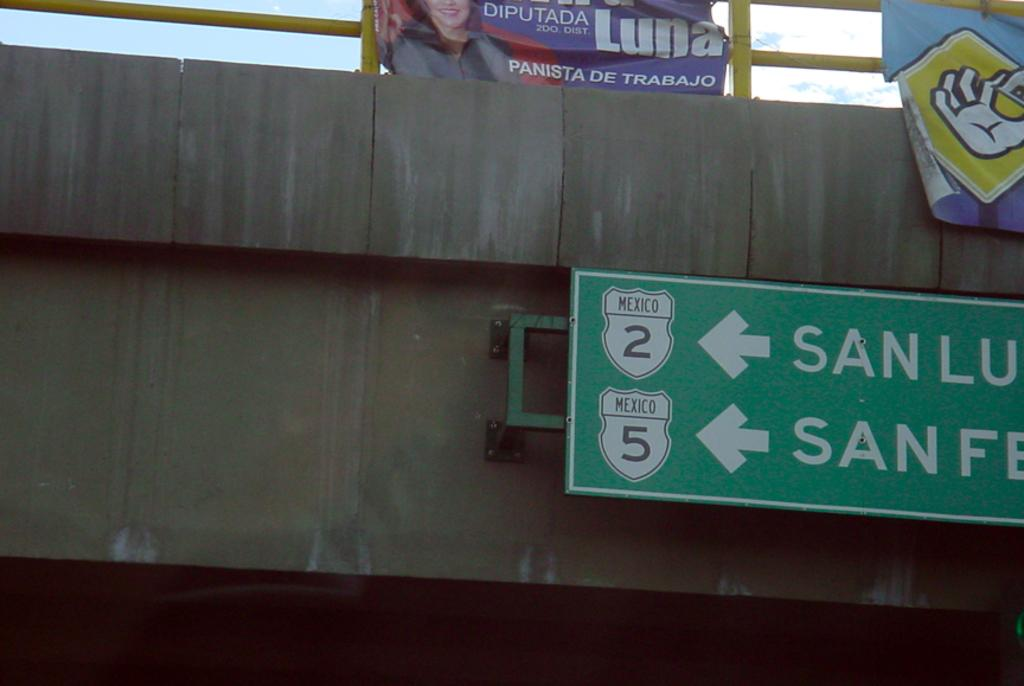Provide a one-sentence caption for the provided image. A highway overpass with left turn signals to get on Highway 2 or Highway 5. 